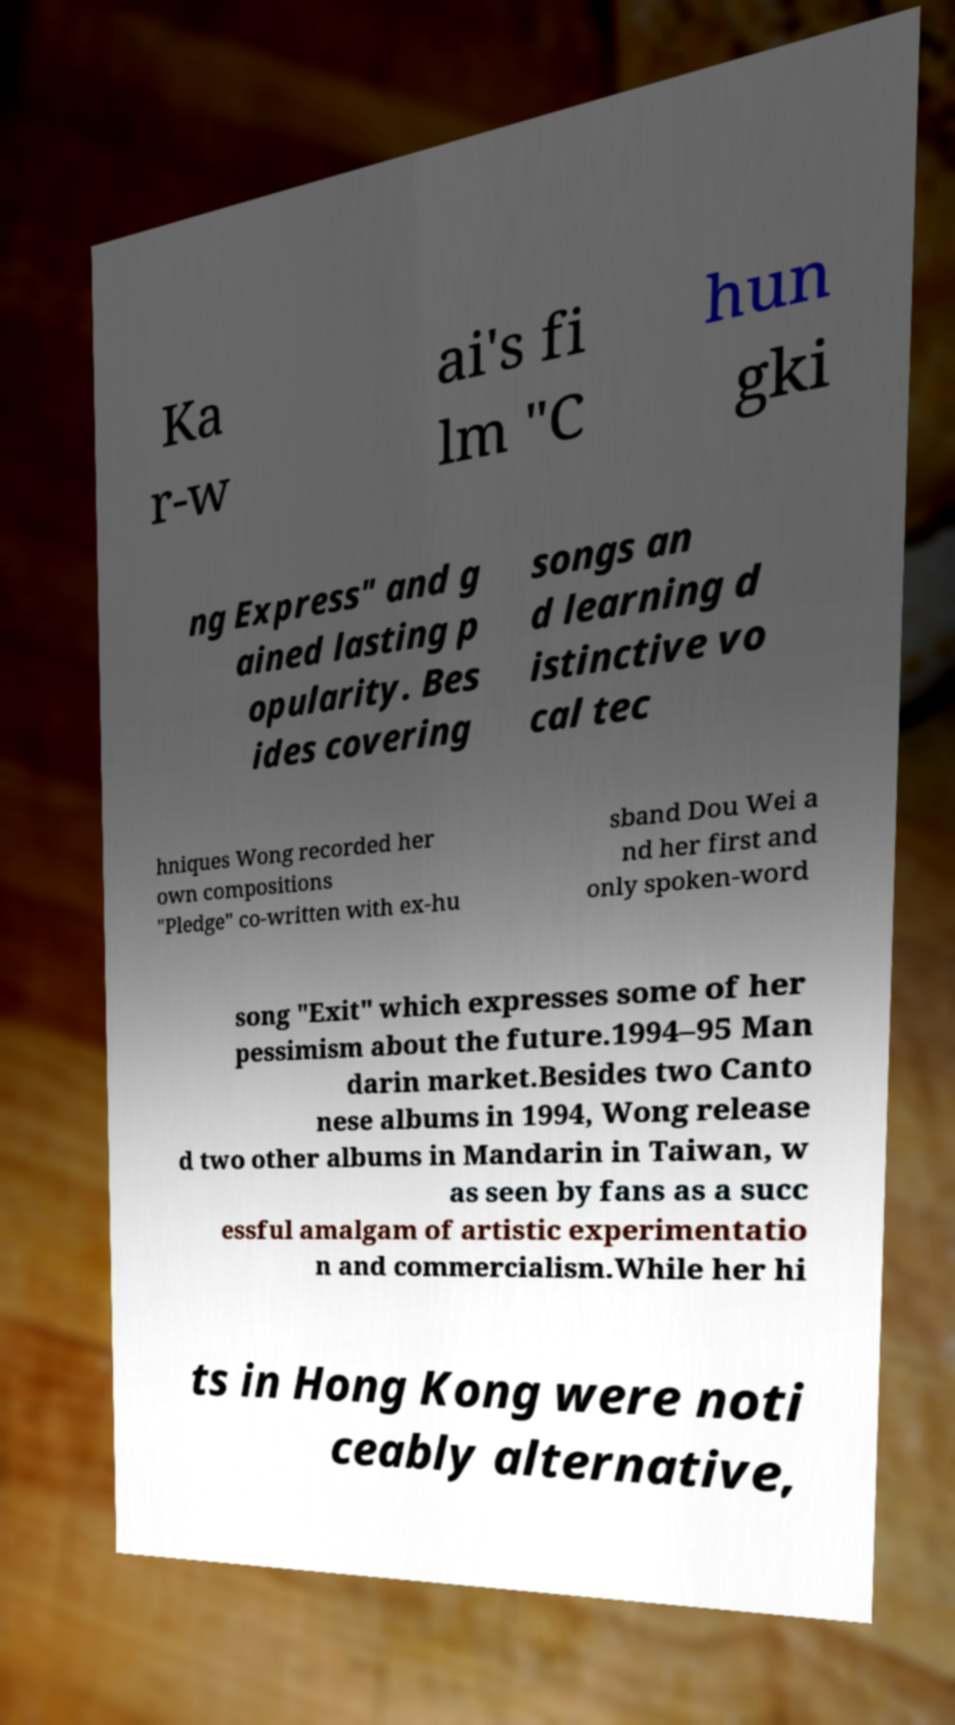Could you assist in decoding the text presented in this image and type it out clearly? Ka r-w ai's fi lm "C hun gki ng Express" and g ained lasting p opularity. Bes ides covering songs an d learning d istinctive vo cal tec hniques Wong recorded her own compositions "Pledge" co-written with ex-hu sband Dou Wei a nd her first and only spoken-word song "Exit" which expresses some of her pessimism about the future.1994–95 Man darin market.Besides two Canto nese albums in 1994, Wong release d two other albums in Mandarin in Taiwan, w as seen by fans as a succ essful amalgam of artistic experimentatio n and commercialism.While her hi ts in Hong Kong were noti ceably alternative, 